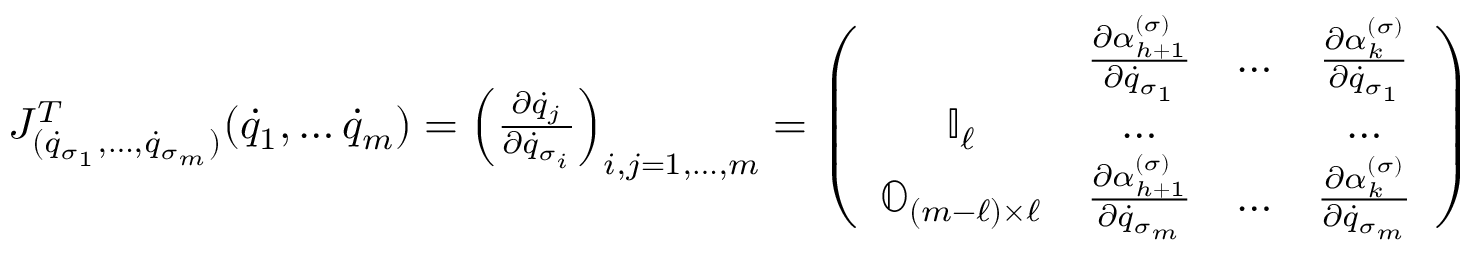<formula> <loc_0><loc_0><loc_500><loc_500>\begin{array} { l } { J _ { ( { \dot { q } } _ { \sigma _ { 1 } } , \dots , { \dot { q } } _ { \sigma _ { m } } ) } ^ { T } ( { \dot { q } } _ { 1 } , \dots { \dot { q } } _ { m } ) = \left ( \frac { \partial { \dot { q } } _ { j } } { \partial { \dot { q } } _ { \sigma _ { i } } } \right ) _ { i , j = 1 , \dots , m } = \left ( \begin{array} { c c c c } & { \frac { \partial \alpha _ { h + 1 } ^ { ( \sigma ) } } { \partial { \dot { q } } _ { \sigma _ { 1 } } } } & { \dots } & { \frac { \partial \alpha _ { k } ^ { ( \sigma ) } } { \partial { \dot { q } } _ { \sigma _ { 1 } } } } \\ { { \mathbb { I } } _ { \ell } } & { \dots } & & { \dots } \\ { { \mathbb { O } } _ { ( m - \ell ) \times \ell } } & { \frac { \partial \alpha _ { h + 1 } ^ { ( \sigma ) } } { \partial { \dot { q } } _ { \sigma _ { m } } } } & { \dots } & { \frac { \partial \alpha _ { k } ^ { ( \sigma ) } } { \partial { \dot { q } } _ { \sigma _ { m } } } } \end{array} \right ) } \end{array}</formula> 